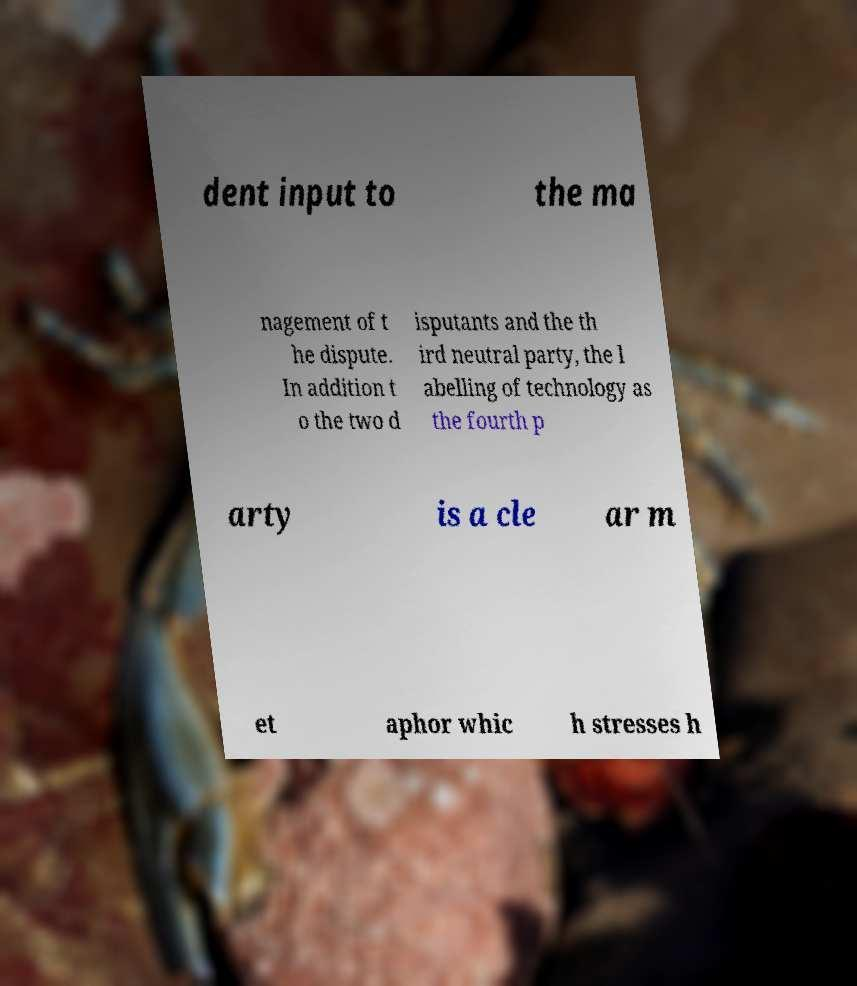I need the written content from this picture converted into text. Can you do that? dent input to the ma nagement of t he dispute. In addition t o the two d isputants and the th ird neutral party, the l abelling of technology as the fourth p arty is a cle ar m et aphor whic h stresses h 